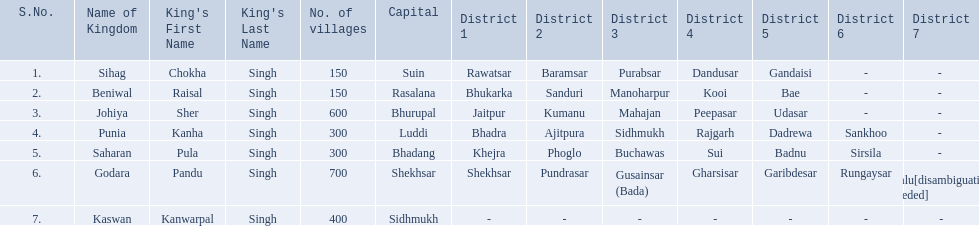What are all of the kingdoms? Sihag, Beniwal, Johiya, Punia, Saharan, Godara, Kaswan. How many villages do they contain? 150, 150, 600, 300, 300, 700, 400. How many are in godara? 700. Which kingdom comes next in highest amount of villages? Johiya. 